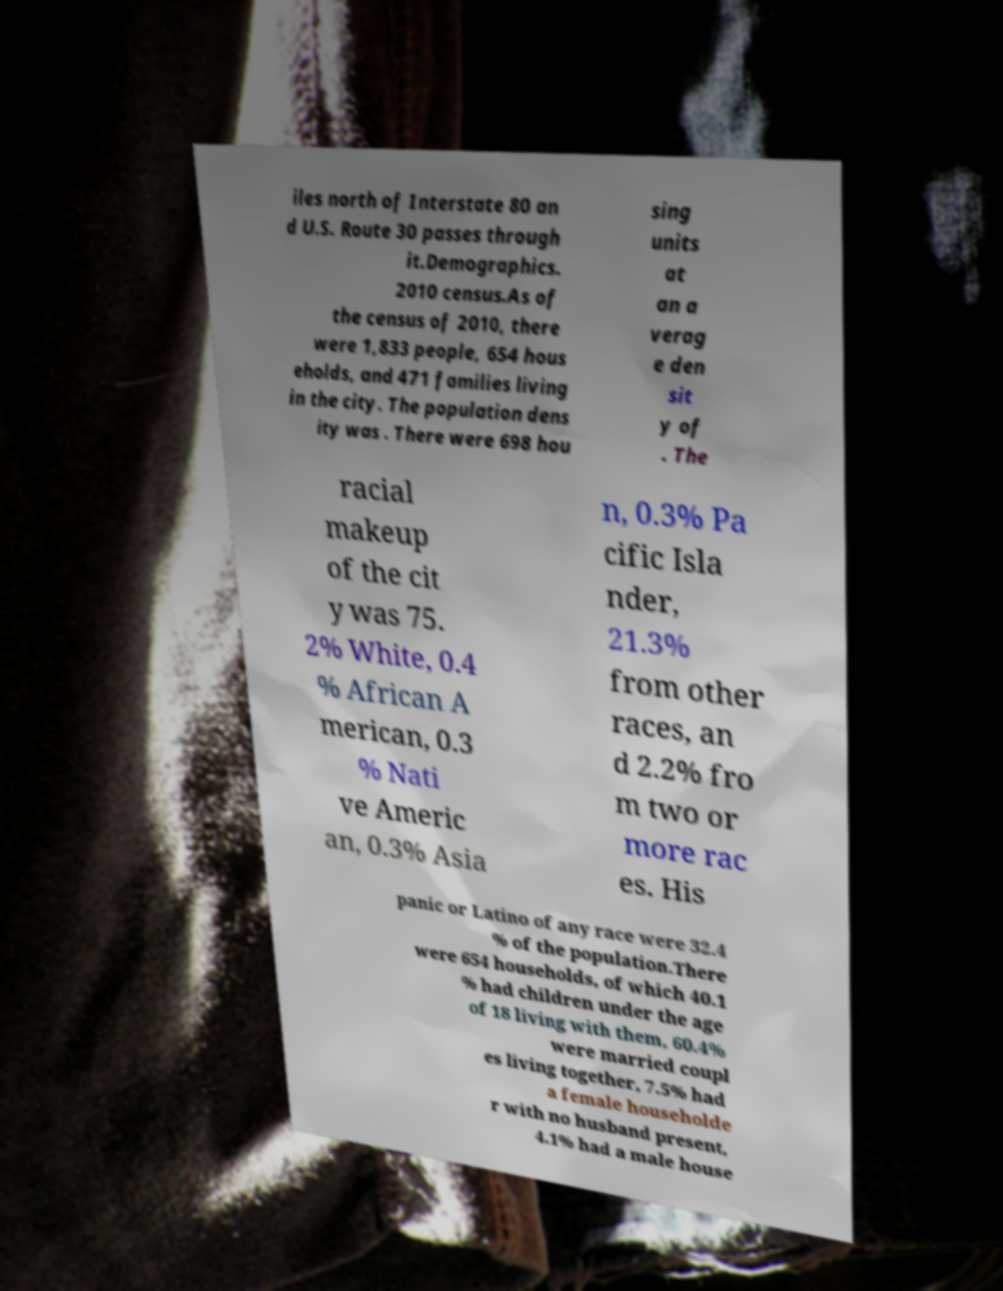There's text embedded in this image that I need extracted. Can you transcribe it verbatim? iles north of Interstate 80 an d U.S. Route 30 passes through it.Demographics. 2010 census.As of the census of 2010, there were 1,833 people, 654 hous eholds, and 471 families living in the city. The population dens ity was . There were 698 hou sing units at an a verag e den sit y of . The racial makeup of the cit y was 75. 2% White, 0.4 % African A merican, 0.3 % Nati ve Americ an, 0.3% Asia n, 0.3% Pa cific Isla nder, 21.3% from other races, an d 2.2% fro m two or more rac es. His panic or Latino of any race were 32.4 % of the population.There were 654 households, of which 40.1 % had children under the age of 18 living with them, 60.4% were married coupl es living together, 7.5% had a female householde r with no husband present, 4.1% had a male house 